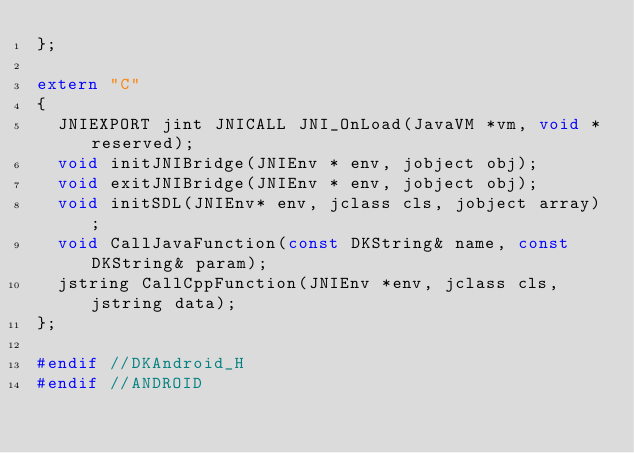<code> <loc_0><loc_0><loc_500><loc_500><_C_>};

extern "C" 
{
	JNIEXPORT jint JNICALL JNI_OnLoad(JavaVM *vm, void *reserved);
	void initJNIBridge(JNIEnv * env, jobject obj);
	void exitJNIBridge(JNIEnv * env, jobject obj);
	void initSDL(JNIEnv* env, jclass cls, jobject array);
	void CallJavaFunction(const DKString& name, const DKString& param);
	jstring CallCppFunction(JNIEnv *env, jclass cls, jstring data);
};

#endif //DKAndroid_H
#endif //ANDROID
</code> 